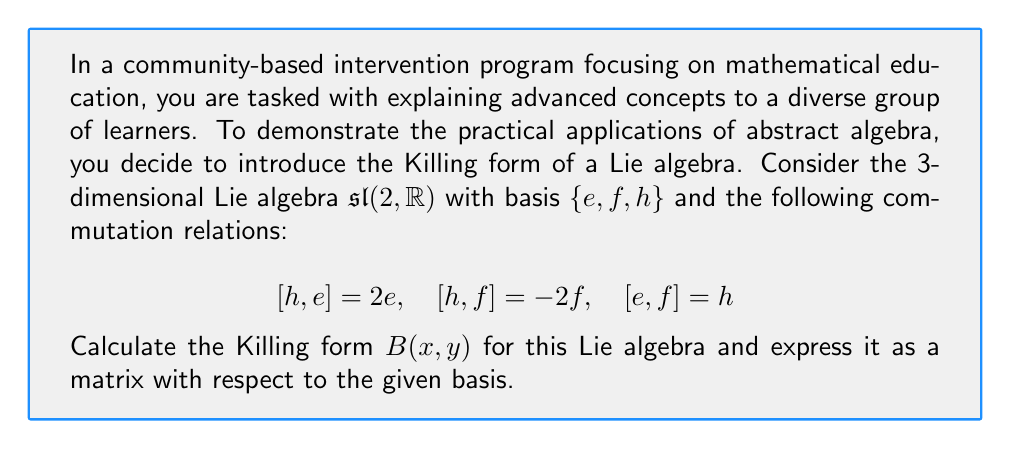Give your solution to this math problem. Let's approach this step-by-step:

1) The Killing form $B(x,y)$ for a Lie algebra is defined as:

   $$B(x,y) = \text{tr}(\text{ad}(x) \circ \text{ad}(y))$$

   where $\text{ad}(x)$ is the adjoint representation of $x$.

2) We need to calculate $\text{ad}(x)$ for each basis element. Let's start with $\text{ad}(h)$:

   $$\text{ad}(h)(e) = [h,e] = 2e$$
   $$\text{ad}(h)(f) = [h,f] = -2f$$
   $$\text{ad}(h)(h) = [h,h] = 0$$

   So, $\text{ad}(h)$ in matrix form is:
   $$\text{ad}(h) = \begin{pmatrix} 2 & 0 & 0 \\ 0 & -2 & 0 \\ 0 & 0 & 0 \end{pmatrix}$$

3) Similarly, for $\text{ad}(e)$:

   $$\text{ad}(e)(e) = [e,e] = 0$$
   $$\text{ad}(e)(f) = [e,f] = h$$
   $$\text{ad}(e)(h) = [e,h] = -2e$$

   So, $\text{ad}(e) = \begin{pmatrix} 0 & 0 & -2 \\ 0 & 0 & 0 \\ 1 & 0 & 0 \end{pmatrix}$

4) And for $\text{ad}(f)$:

   $$\text{ad}(f)(e) = [f,e] = -h$$
   $$\text{ad}(f)(f) = [f,f] = 0$$
   $$\text{ad}(f)(h) = [f,h] = 2f$$

   So, $\text{ad}(f) = \begin{pmatrix} 0 & 0 & 0 \\ -1 & 0 & 2 \\ 0 & 0 & 0 \end{pmatrix}$

5) Now, we can calculate the Killing form for each pair of basis elements:

   $B(h,h) = \text{tr}(\text{ad}(h) \circ \text{ad}(h)) = 2^2 + (-2)^2 + 0^2 = 8$
   
   $B(e,f) = \text{tr}(\text{ad}(e) \circ \text{ad}(f)) = 0 + 0 + 4 = 4$
   
   $B(e,e) = B(f,f) = 0$ (because $\text{ad}(e)^2$ and $\text{ad}(f)^2$ are nilpotent)
   
   $B(h,e) = B(h,f) = 0$ (due to the properties of trace)

6) The Killing form is symmetric, so $B(f,e) = B(e,f) = 4$.

7) Therefore, the Killing form as a matrix with respect to the basis $\{e,f,h\}$ is:

   $$B = \begin{pmatrix} 0 & 4 & 0 \\ 4 & 0 & 0 \\ 0 & 0 & 8 \end{pmatrix}$$
Answer: The Killing form for the Lie algebra $\mathfrak{sl}(2,\mathbb{R})$ with respect to the basis $\{e,f,h\}$ is:

$$B = \begin{pmatrix} 0 & 4 & 0 \\ 4 & 0 & 0 \\ 0 & 0 & 8 \end{pmatrix}$$ 